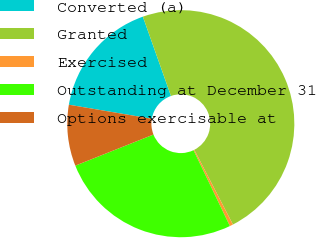<chart> <loc_0><loc_0><loc_500><loc_500><pie_chart><fcel>Converted (a)<fcel>Granted<fcel>Exercised<fcel>Outstanding at December 31<fcel>Options exercisable at<nl><fcel>16.91%<fcel>47.83%<fcel>0.48%<fcel>26.09%<fcel>8.7%<nl></chart> 